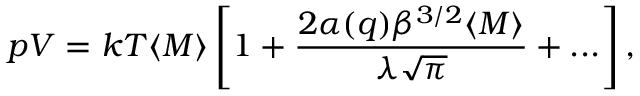Convert formula to latex. <formula><loc_0><loc_0><loc_500><loc_500>p V = k T \langle M \rangle \left [ 1 + \frac { 2 \alpha ( q ) \beta ^ { 3 / 2 } \langle M \rangle } { \lambda \sqrt { \pi } } + \dots \right ] ,</formula> 